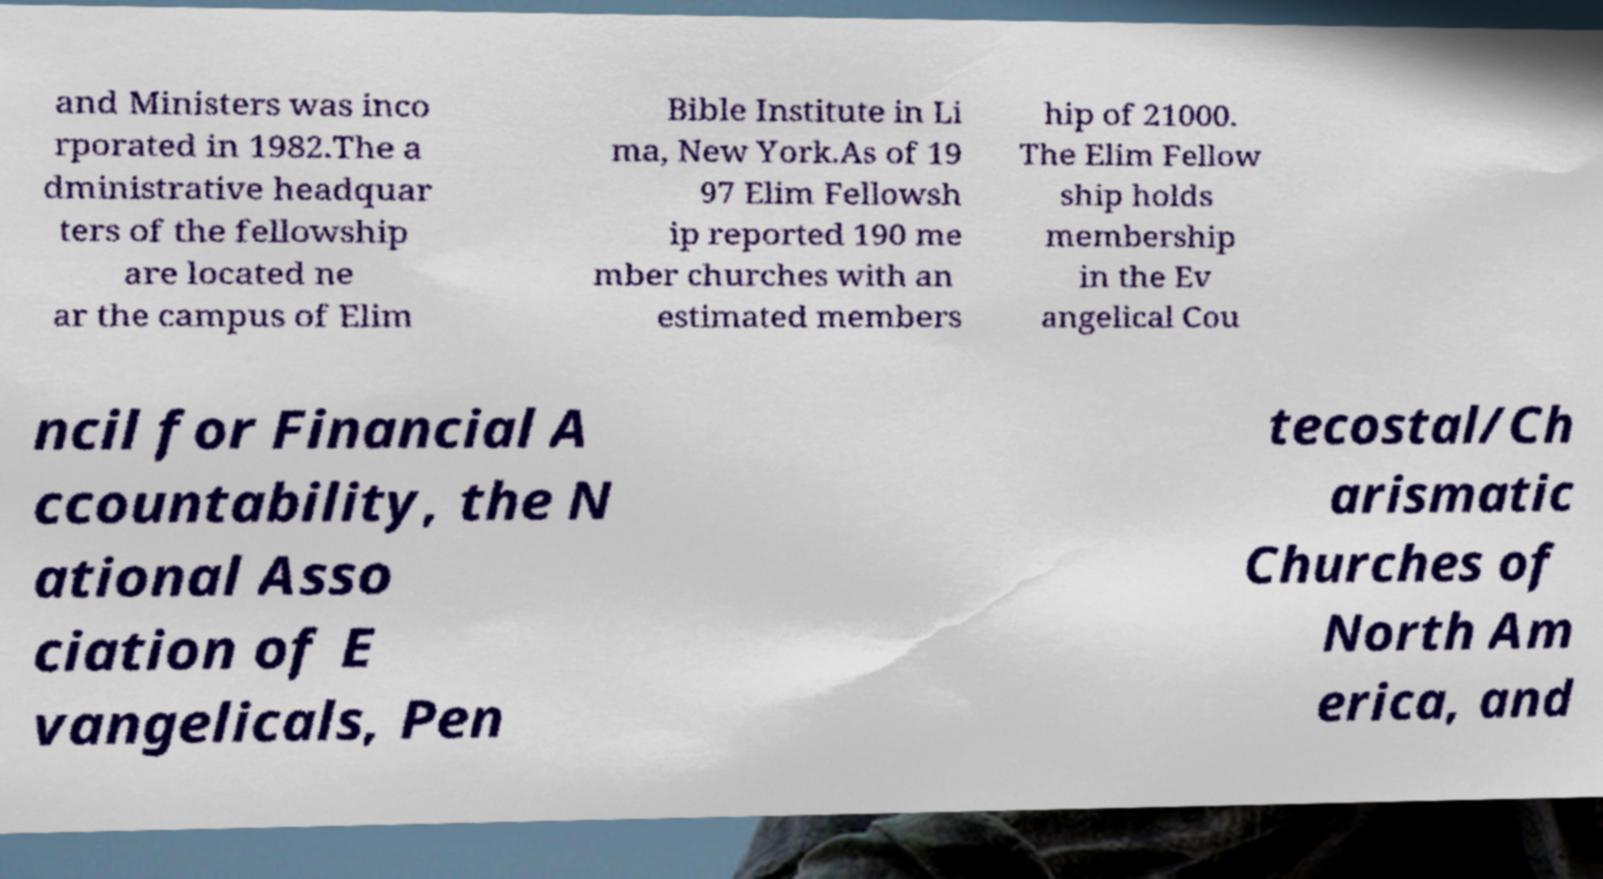I need the written content from this picture converted into text. Can you do that? and Ministers was inco rporated in 1982.The a dministrative headquar ters of the fellowship are located ne ar the campus of Elim Bible Institute in Li ma, New York.As of 19 97 Elim Fellowsh ip reported 190 me mber churches with an estimated members hip of 21000. The Elim Fellow ship holds membership in the Ev angelical Cou ncil for Financial A ccountability, the N ational Asso ciation of E vangelicals, Pen tecostal/Ch arismatic Churches of North Am erica, and 